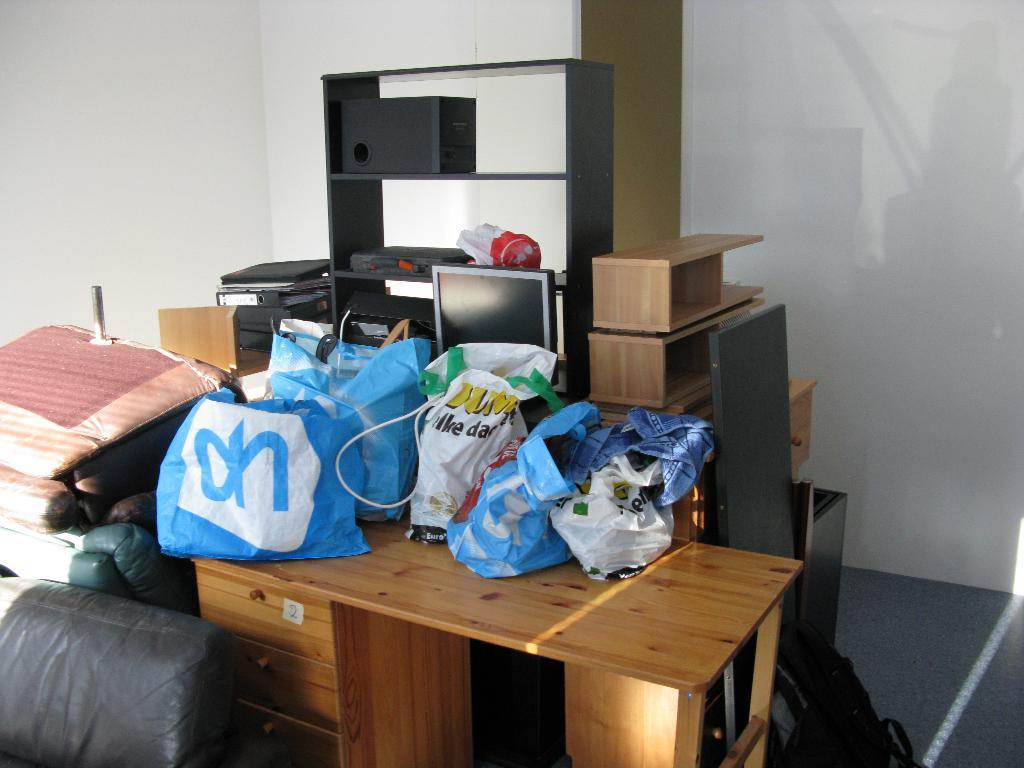What is the setting of the image? The image is inside a room. What objects are on the table in the image? There are bags, computers, speakers, and covers on the table. Can you see the sea from inside the room in the image? There is no reference to a sea or any outdoor elements in the image, so it is not possible to determine if the sea is visible. What type of roll is being used to cover the computers in the image? There is no roll present in the image; it features bags, computers, speakers, and covers on the table. 